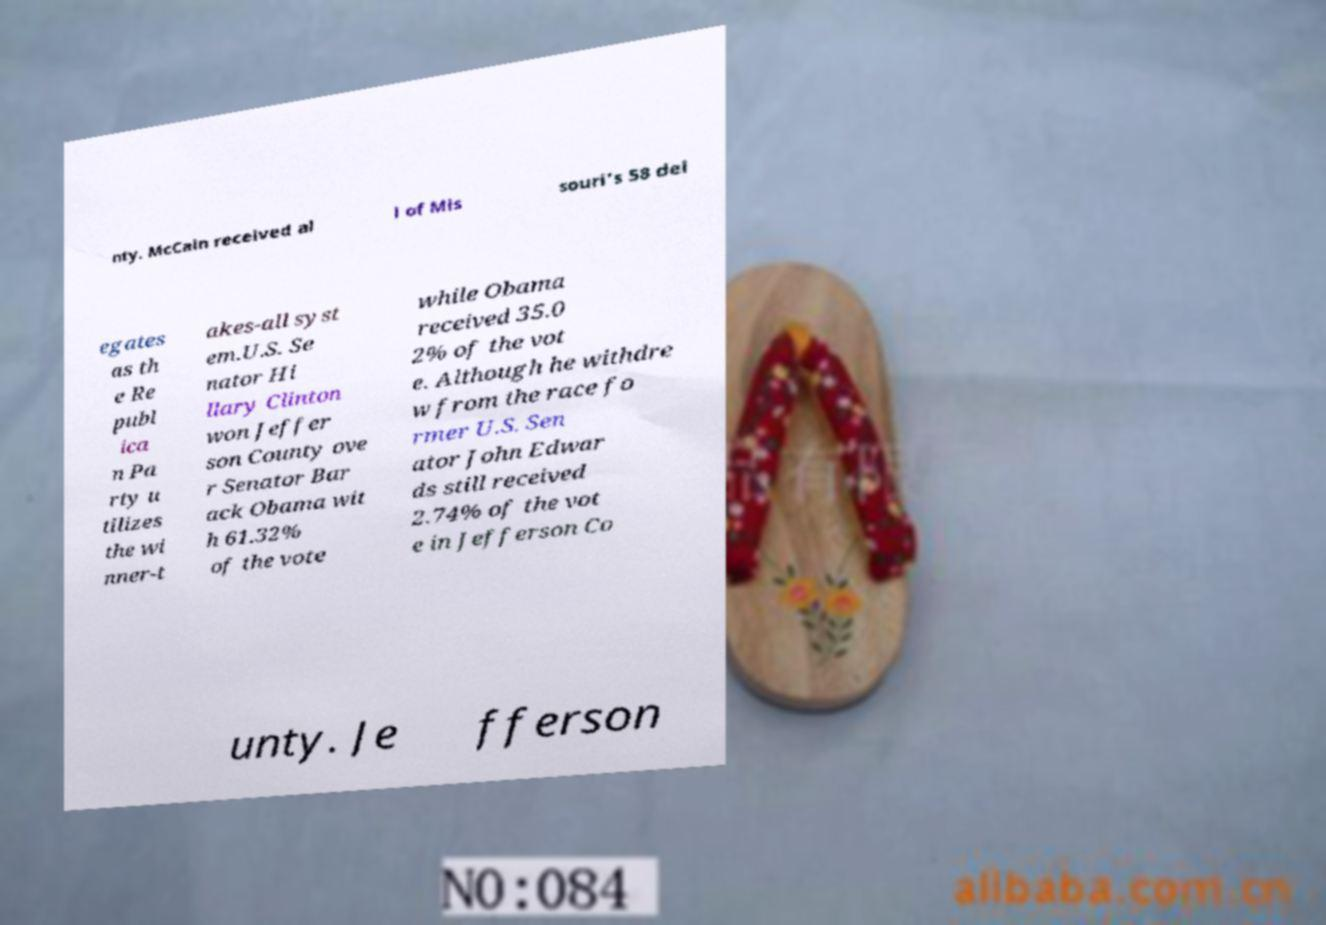Could you extract and type out the text from this image? nty. McCain received al l of Mis souri's 58 del egates as th e Re publ ica n Pa rty u tilizes the wi nner-t akes-all syst em.U.S. Se nator Hi llary Clinton won Jeffer son County ove r Senator Bar ack Obama wit h 61.32% of the vote while Obama received 35.0 2% of the vot e. Although he withdre w from the race fo rmer U.S. Sen ator John Edwar ds still received 2.74% of the vot e in Jefferson Co unty. Je fferson 